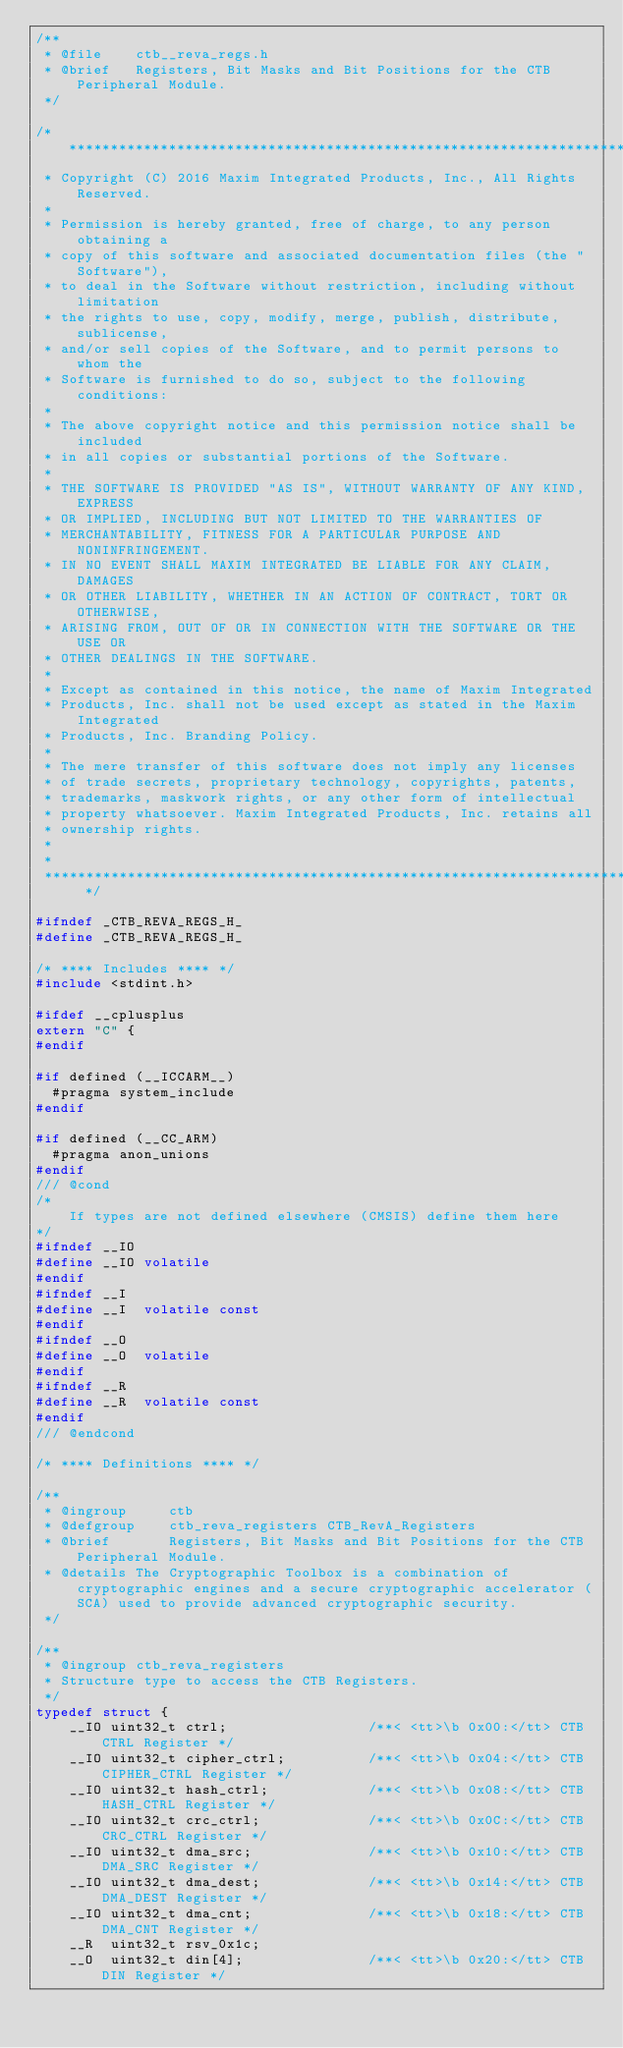<code> <loc_0><loc_0><loc_500><loc_500><_C_>/**
 * @file    ctb__reva_regs.h
 * @brief   Registers, Bit Masks and Bit Positions for the CTB Peripheral Module.
 */

/* ****************************************************************************
 * Copyright (C) 2016 Maxim Integrated Products, Inc., All Rights Reserved.
 *
 * Permission is hereby granted, free of charge, to any person obtaining a
 * copy of this software and associated documentation files (the "Software"),
 * to deal in the Software without restriction, including without limitation
 * the rights to use, copy, modify, merge, publish, distribute, sublicense,
 * and/or sell copies of the Software, and to permit persons to whom the
 * Software is furnished to do so, subject to the following conditions:
 *
 * The above copyright notice and this permission notice shall be included
 * in all copies or substantial portions of the Software.
 *
 * THE SOFTWARE IS PROVIDED "AS IS", WITHOUT WARRANTY OF ANY KIND, EXPRESS
 * OR IMPLIED, INCLUDING BUT NOT LIMITED TO THE WARRANTIES OF
 * MERCHANTABILITY, FITNESS FOR A PARTICULAR PURPOSE AND NONINFRINGEMENT.
 * IN NO EVENT SHALL MAXIM INTEGRATED BE LIABLE FOR ANY CLAIM, DAMAGES
 * OR OTHER LIABILITY, WHETHER IN AN ACTION OF CONTRACT, TORT OR OTHERWISE,
 * ARISING FROM, OUT OF OR IN CONNECTION WITH THE SOFTWARE OR THE USE OR
 * OTHER DEALINGS IN THE SOFTWARE.
 *
 * Except as contained in this notice, the name of Maxim Integrated
 * Products, Inc. shall not be used except as stated in the Maxim Integrated
 * Products, Inc. Branding Policy.
 *
 * The mere transfer of this software does not imply any licenses
 * of trade secrets, proprietary technology, copyrights, patents,
 * trademarks, maskwork rights, or any other form of intellectual
 * property whatsoever. Maxim Integrated Products, Inc. retains all
 * ownership rights.
 *
 *
 *************************************************************************** */

#ifndef _CTB_REVA_REGS_H_
#define _CTB_REVA_REGS_H_

/* **** Includes **** */
#include <stdint.h>

#ifdef __cplusplus
extern "C" {
#endif
 
#if defined (__ICCARM__)
  #pragma system_include
#endif
 
#if defined (__CC_ARM)
  #pragma anon_unions
#endif
/// @cond
/*
    If types are not defined elsewhere (CMSIS) define them here
*/
#ifndef __IO
#define __IO volatile
#endif
#ifndef __I
#define __I  volatile const
#endif
#ifndef __O
#define __O  volatile
#endif
#ifndef __R
#define __R  volatile const
#endif
/// @endcond

/* **** Definitions **** */

/**
 * @ingroup     ctb
 * @defgroup    ctb_reva_registers CTB_RevA_Registers
 * @brief       Registers, Bit Masks and Bit Positions for the CTB Peripheral Module.
 * @details The Cryptographic Toolbox is a combination of cryptographic engines and a secure cryptographic accelerator (SCA) used to provide advanced cryptographic security.
 */

/**
 * @ingroup ctb_reva_registers
 * Structure type to access the CTB Registers.
 */
typedef struct {
    __IO uint32_t ctrl;                 /**< <tt>\b 0x00:</tt> CTB CTRL Register */
    __IO uint32_t cipher_ctrl;          /**< <tt>\b 0x04:</tt> CTB CIPHER_CTRL Register */
    __IO uint32_t hash_ctrl;            /**< <tt>\b 0x08:</tt> CTB HASH_CTRL Register */
    __IO uint32_t crc_ctrl;             /**< <tt>\b 0x0C:</tt> CTB CRC_CTRL Register */
    __IO uint32_t dma_src;              /**< <tt>\b 0x10:</tt> CTB DMA_SRC Register */
    __IO uint32_t dma_dest;             /**< <tt>\b 0x14:</tt> CTB DMA_DEST Register */
    __IO uint32_t dma_cnt;              /**< <tt>\b 0x18:</tt> CTB DMA_CNT Register */
    __R  uint32_t rsv_0x1c;
    __O  uint32_t din[4];               /**< <tt>\b 0x20:</tt> CTB DIN Register */</code> 